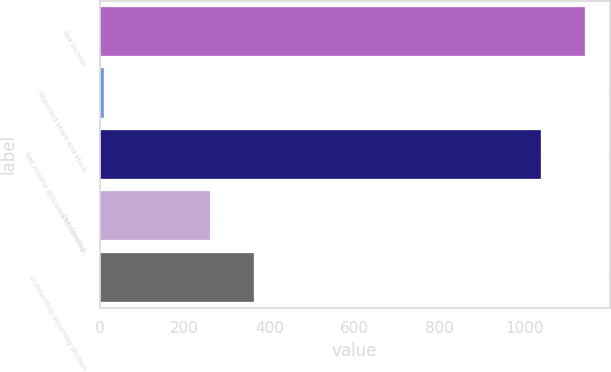Convert chart to OTSL. <chart><loc_0><loc_0><loc_500><loc_500><bar_chart><fcel>Net income<fcel>restricted share and stock<fcel>Net income allocated to common<fcel>Outstanding<fcel>Outstanding assuming dilution<nl><fcel>1142.24<fcel>9.3<fcel>1038.4<fcel>258.3<fcel>362.14<nl></chart> 